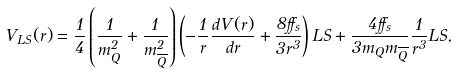<formula> <loc_0><loc_0><loc_500><loc_500>V _ { L S } ( r ) = \frac { 1 } { 4 } \left ( \frac { 1 } { m _ { Q } ^ { 2 } } + \frac { 1 } { m _ { \overline { Q } } ^ { 2 } } \right ) \left ( - \frac { 1 } { r } \frac { d V ( r ) } { d r } + \frac { 8 \alpha _ { s } } { 3 r ^ { 3 } } \right ) { L S } + \frac { 4 \alpha _ { s } } { 3 m _ { Q } m _ { \overline { Q } } } \frac { 1 } { r ^ { 3 } } { L S } ,</formula> 